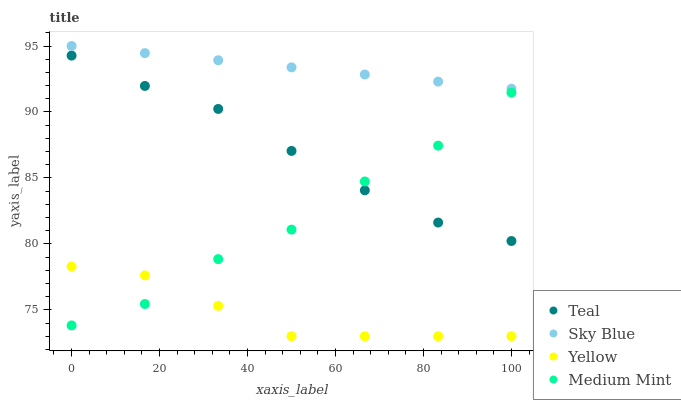Does Yellow have the minimum area under the curve?
Answer yes or no. Yes. Does Sky Blue have the maximum area under the curve?
Answer yes or no. Yes. Does Sky Blue have the minimum area under the curve?
Answer yes or no. No. Does Yellow have the maximum area under the curve?
Answer yes or no. No. Is Sky Blue the smoothest?
Answer yes or no. Yes. Is Medium Mint the roughest?
Answer yes or no. Yes. Is Yellow the smoothest?
Answer yes or no. No. Is Yellow the roughest?
Answer yes or no. No. Does Yellow have the lowest value?
Answer yes or no. Yes. Does Sky Blue have the lowest value?
Answer yes or no. No. Does Sky Blue have the highest value?
Answer yes or no. Yes. Does Yellow have the highest value?
Answer yes or no. No. Is Yellow less than Teal?
Answer yes or no. Yes. Is Teal greater than Yellow?
Answer yes or no. Yes. Does Teal intersect Medium Mint?
Answer yes or no. Yes. Is Teal less than Medium Mint?
Answer yes or no. No. Is Teal greater than Medium Mint?
Answer yes or no. No. Does Yellow intersect Teal?
Answer yes or no. No. 